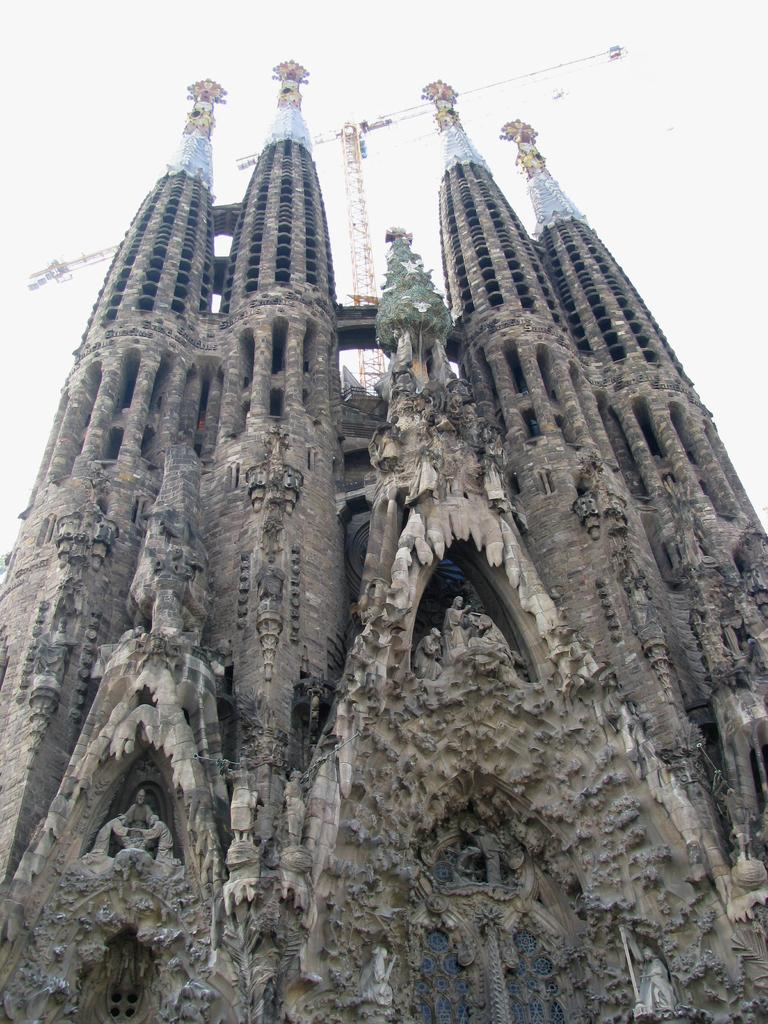What structure is the main subject of the image? There is a building in the image. What can be seen behind the building? There is a crane behind the building. What is visible at the top of the image? The sky is visible at the top of the image. How many pizzas are being delivered by the railway in the image? There are no pizzas or railway present in the image. Can you see a swing in the image? There is no swing present in the image. 